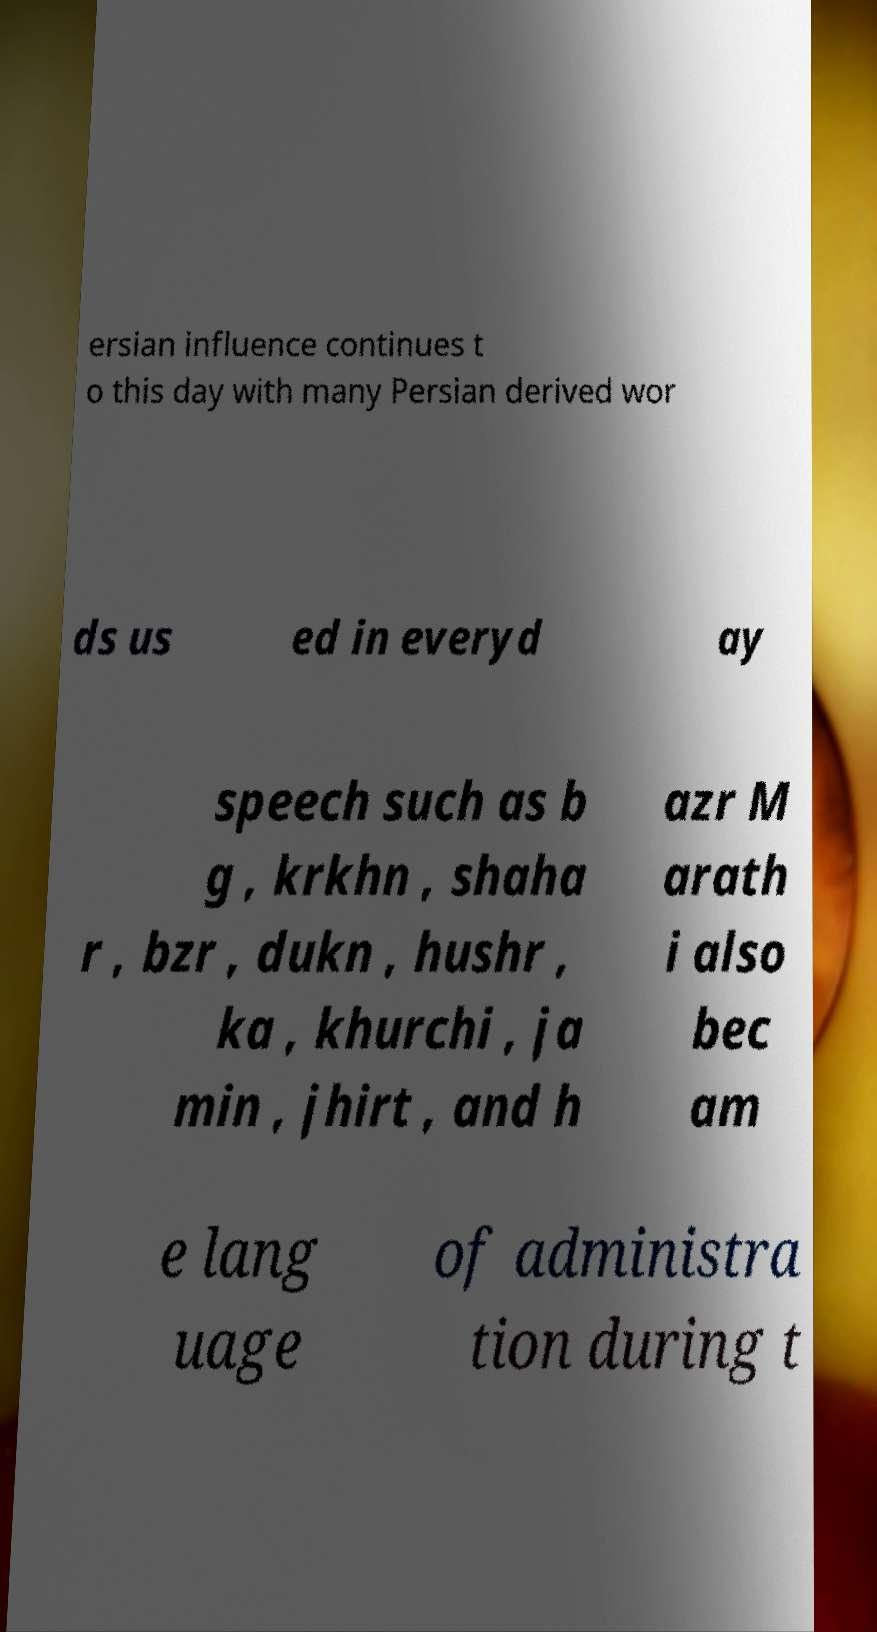I need the written content from this picture converted into text. Can you do that? ersian influence continues t o this day with many Persian derived wor ds us ed in everyd ay speech such as b g , krkhn , shaha r , bzr , dukn , hushr , ka , khurchi , ja min , jhirt , and h azr M arath i also bec am e lang uage of administra tion during t 